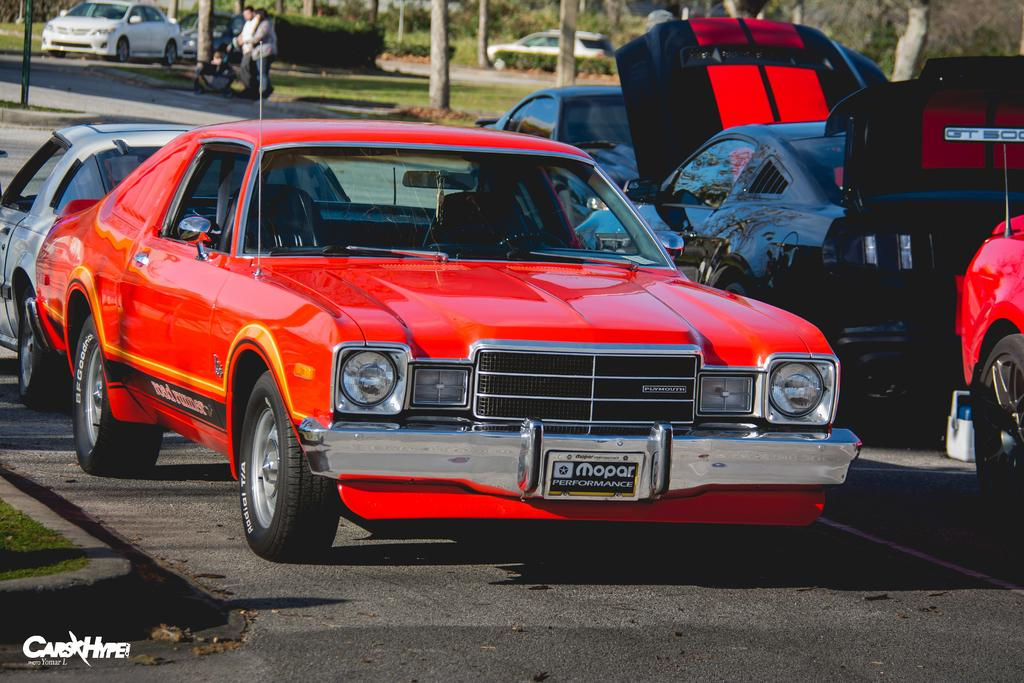What can be found in the bottom left-hand side of the image? There is a watermark in the bottom left-hand side of the image. What is located in the middle of the image? There are vehicles in the middle of the image. How many persons are visible at the top of the image? There are two persons visible at the top of the image. What type of vegetation is present in the image? Bushes and trees are visible in the image. What type of produce is being stored in the vase in the image? There is no vase or produce present in the image. 